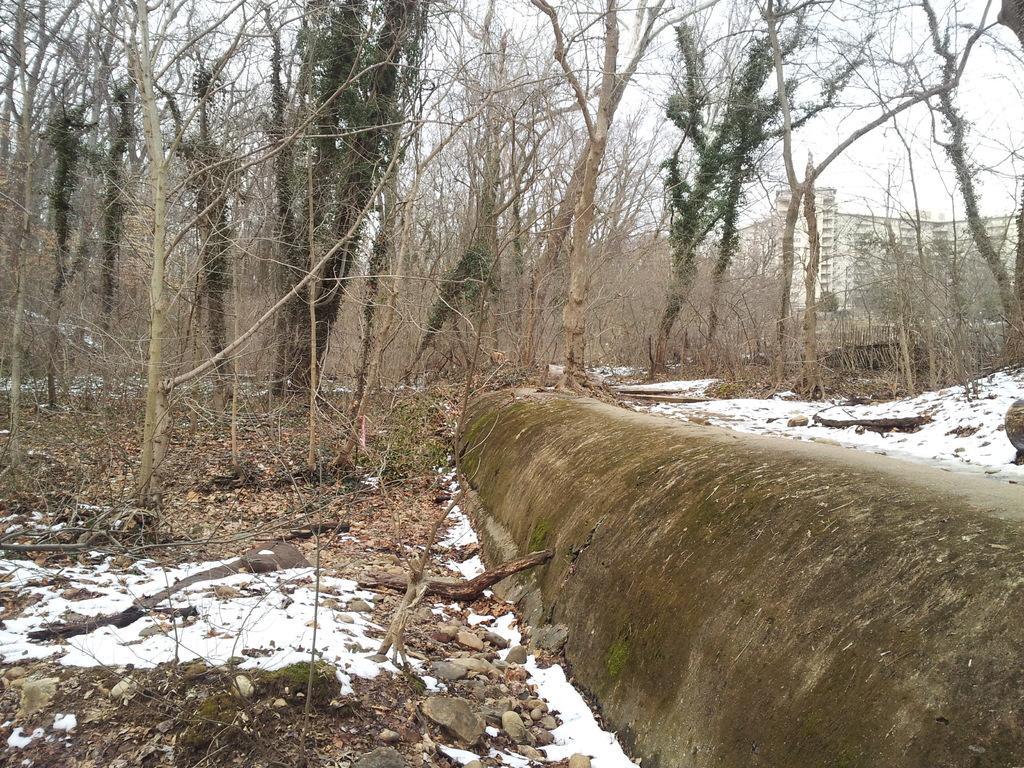Could you give a brief overview of what you see in this image? In this picture, we see trees, stones and twigs. In the background, there are trees and a building. This building is in white color. 